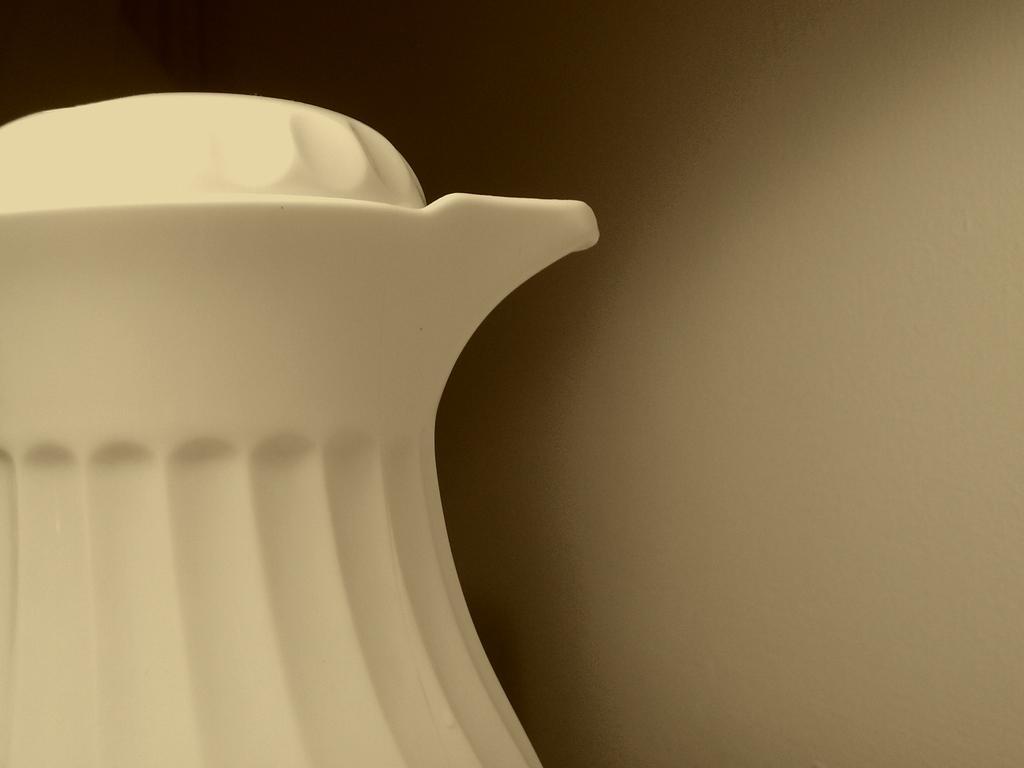Please provide a concise description of this image. In this picture I can see a jug and I can see plain background 